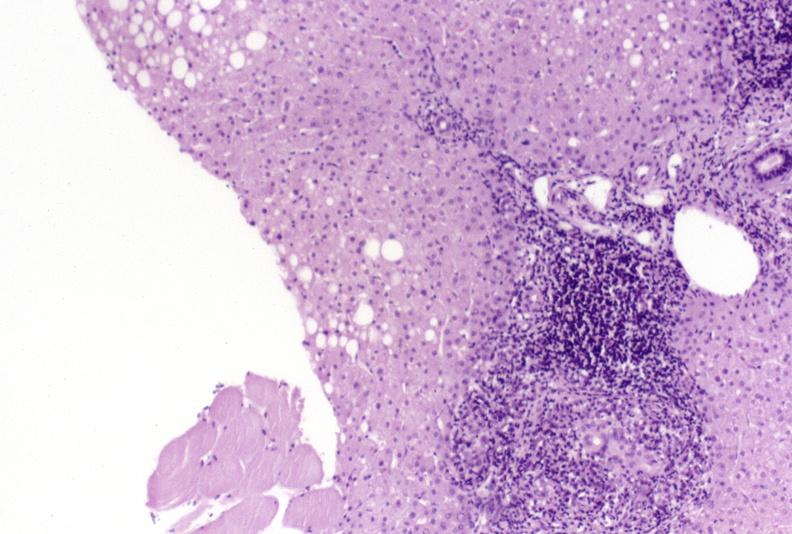what does this image show?
Answer the question using a single word or phrase. Primary biliary cirrhosis 